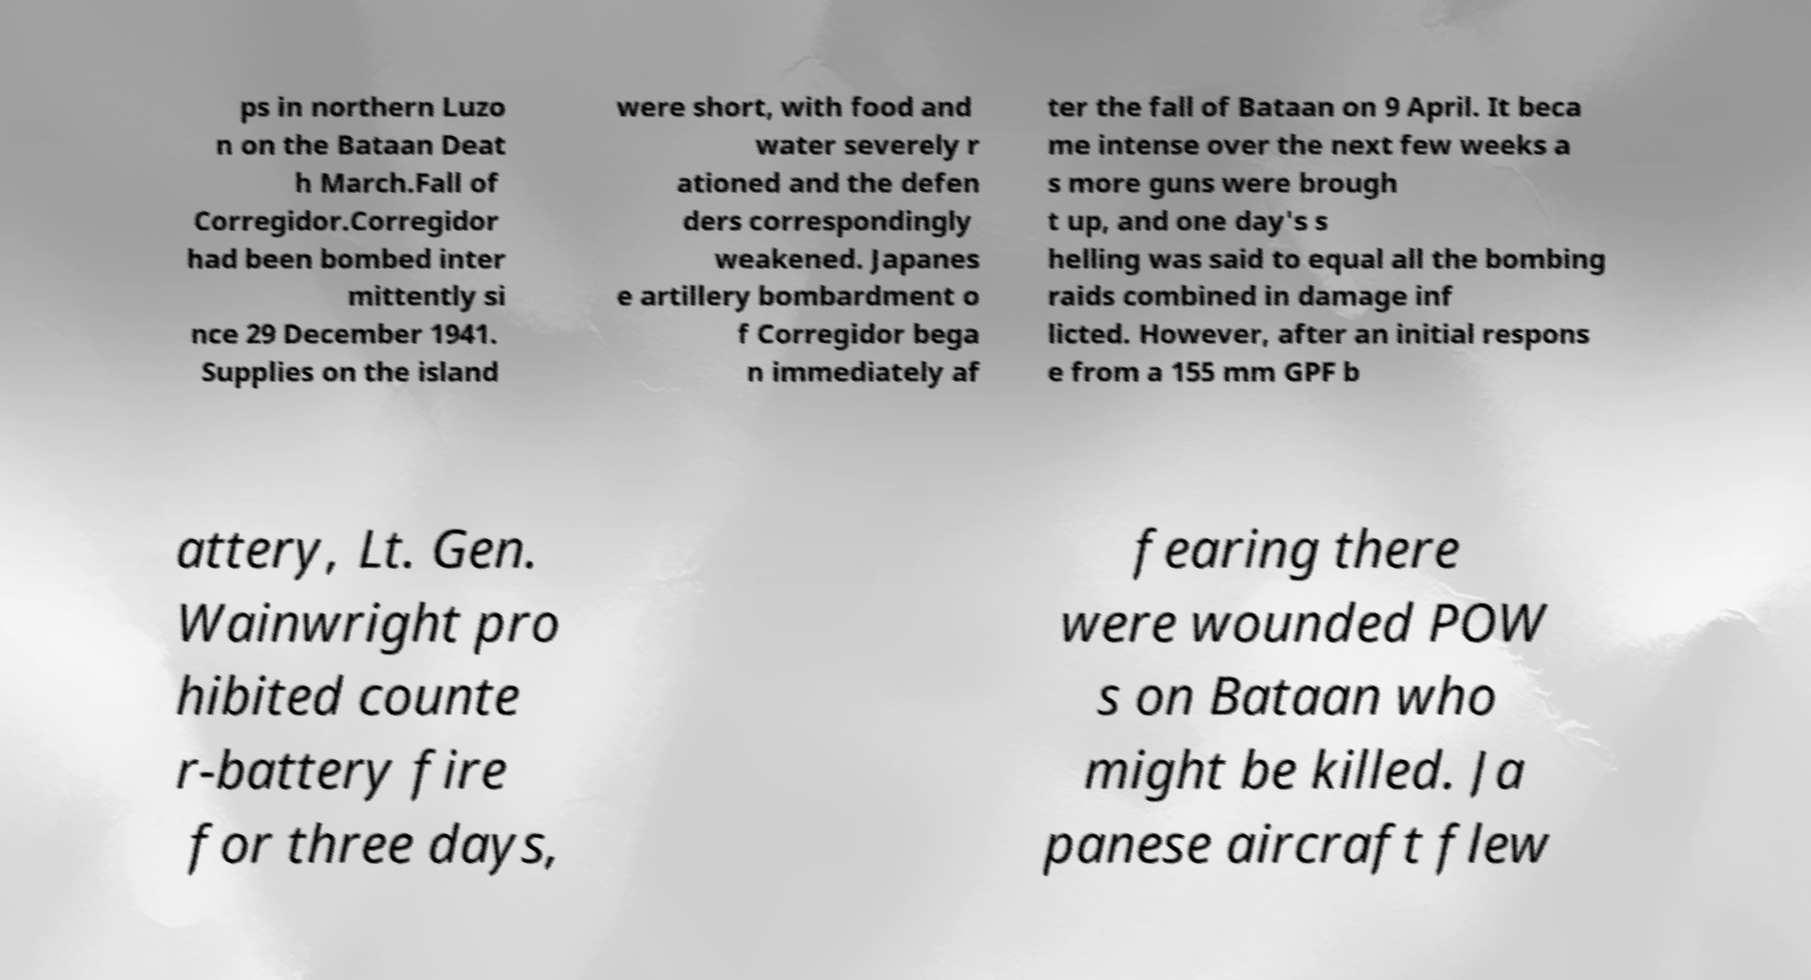Please read and relay the text visible in this image. What does it say? ps in northern Luzo n on the Bataan Deat h March.Fall of Corregidor.Corregidor had been bombed inter mittently si nce 29 December 1941. Supplies on the island were short, with food and water severely r ationed and the defen ders correspondingly weakened. Japanes e artillery bombardment o f Corregidor bega n immediately af ter the fall of Bataan on 9 April. It beca me intense over the next few weeks a s more guns were brough t up, and one day's s helling was said to equal all the bombing raids combined in damage inf licted. However, after an initial respons e from a 155 mm GPF b attery, Lt. Gen. Wainwright pro hibited counte r-battery fire for three days, fearing there were wounded POW s on Bataan who might be killed. Ja panese aircraft flew 